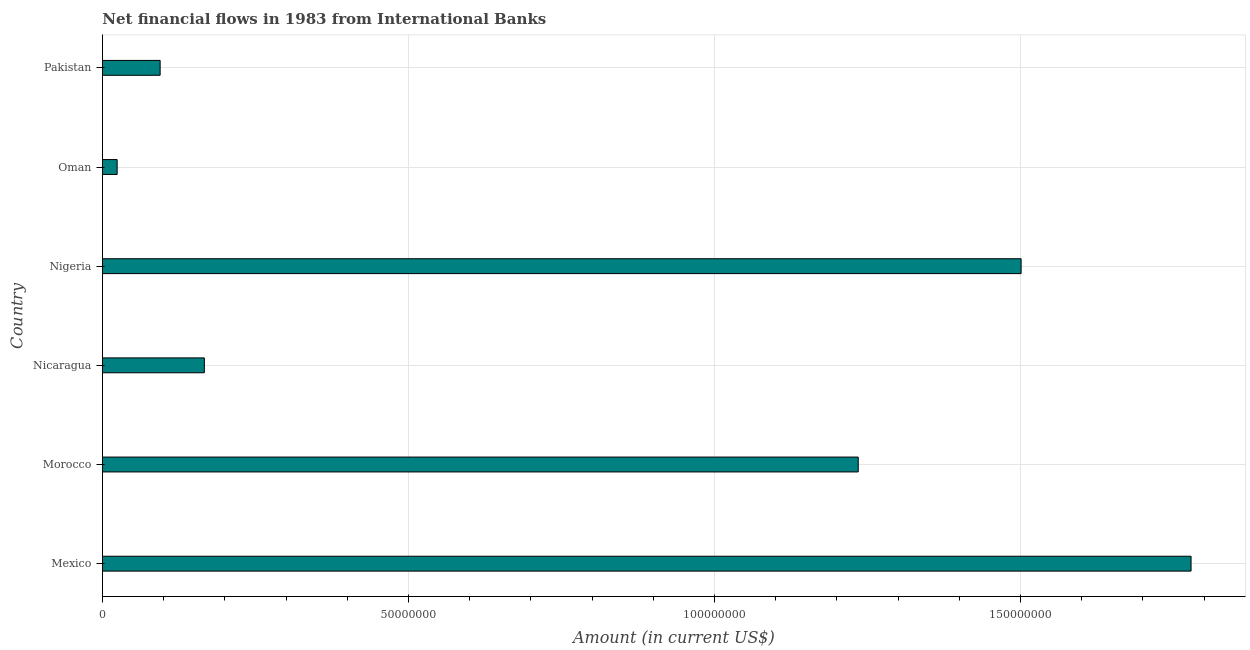Does the graph contain grids?
Your response must be concise. Yes. What is the title of the graph?
Offer a very short reply. Net financial flows in 1983 from International Banks. What is the label or title of the X-axis?
Your response must be concise. Amount (in current US$). What is the label or title of the Y-axis?
Give a very brief answer. Country. What is the net financial flows from ibrd in Mexico?
Your response must be concise. 1.78e+08. Across all countries, what is the maximum net financial flows from ibrd?
Provide a succinct answer. 1.78e+08. Across all countries, what is the minimum net financial flows from ibrd?
Ensure brevity in your answer.  2.40e+06. In which country was the net financial flows from ibrd maximum?
Ensure brevity in your answer.  Mexico. In which country was the net financial flows from ibrd minimum?
Make the answer very short. Oman. What is the sum of the net financial flows from ibrd?
Make the answer very short. 4.80e+08. What is the difference between the net financial flows from ibrd in Mexico and Oman?
Your answer should be very brief. 1.75e+08. What is the average net financial flows from ibrd per country?
Your response must be concise. 8.00e+07. What is the median net financial flows from ibrd?
Keep it short and to the point. 7.01e+07. What is the ratio of the net financial flows from ibrd in Nicaragua to that in Pakistan?
Offer a very short reply. 1.77. Is the net financial flows from ibrd in Oman less than that in Pakistan?
Keep it short and to the point. Yes. What is the difference between the highest and the second highest net financial flows from ibrd?
Keep it short and to the point. 2.78e+07. What is the difference between the highest and the lowest net financial flows from ibrd?
Your answer should be very brief. 1.75e+08. How many countries are there in the graph?
Ensure brevity in your answer.  6. What is the difference between two consecutive major ticks on the X-axis?
Your answer should be compact. 5.00e+07. Are the values on the major ticks of X-axis written in scientific E-notation?
Provide a succinct answer. No. What is the Amount (in current US$) of Mexico?
Offer a very short reply. 1.78e+08. What is the Amount (in current US$) in Morocco?
Keep it short and to the point. 1.23e+08. What is the Amount (in current US$) of Nicaragua?
Offer a very short reply. 1.66e+07. What is the Amount (in current US$) in Nigeria?
Keep it short and to the point. 1.50e+08. What is the Amount (in current US$) of Oman?
Your answer should be compact. 2.40e+06. What is the Amount (in current US$) of Pakistan?
Make the answer very short. 9.42e+06. What is the difference between the Amount (in current US$) in Mexico and Morocco?
Offer a terse response. 5.44e+07. What is the difference between the Amount (in current US$) in Mexico and Nicaragua?
Provide a short and direct response. 1.61e+08. What is the difference between the Amount (in current US$) in Mexico and Nigeria?
Ensure brevity in your answer.  2.78e+07. What is the difference between the Amount (in current US$) in Mexico and Oman?
Your response must be concise. 1.75e+08. What is the difference between the Amount (in current US$) in Mexico and Pakistan?
Your response must be concise. 1.68e+08. What is the difference between the Amount (in current US$) in Morocco and Nicaragua?
Offer a very short reply. 1.07e+08. What is the difference between the Amount (in current US$) in Morocco and Nigeria?
Offer a very short reply. -2.66e+07. What is the difference between the Amount (in current US$) in Morocco and Oman?
Keep it short and to the point. 1.21e+08. What is the difference between the Amount (in current US$) in Morocco and Pakistan?
Offer a very short reply. 1.14e+08. What is the difference between the Amount (in current US$) in Nicaragua and Nigeria?
Your answer should be compact. -1.33e+08. What is the difference between the Amount (in current US$) in Nicaragua and Oman?
Give a very brief answer. 1.42e+07. What is the difference between the Amount (in current US$) in Nicaragua and Pakistan?
Provide a short and direct response. 7.22e+06. What is the difference between the Amount (in current US$) in Nigeria and Oman?
Give a very brief answer. 1.48e+08. What is the difference between the Amount (in current US$) in Nigeria and Pakistan?
Offer a very short reply. 1.41e+08. What is the difference between the Amount (in current US$) in Oman and Pakistan?
Offer a terse response. -7.02e+06. What is the ratio of the Amount (in current US$) in Mexico to that in Morocco?
Give a very brief answer. 1.44. What is the ratio of the Amount (in current US$) in Mexico to that in Nicaragua?
Keep it short and to the point. 10.69. What is the ratio of the Amount (in current US$) in Mexico to that in Nigeria?
Give a very brief answer. 1.19. What is the ratio of the Amount (in current US$) in Mexico to that in Oman?
Your response must be concise. 74.11. What is the ratio of the Amount (in current US$) in Mexico to that in Pakistan?
Ensure brevity in your answer.  18.88. What is the ratio of the Amount (in current US$) in Morocco to that in Nicaragua?
Offer a terse response. 7.42. What is the ratio of the Amount (in current US$) in Morocco to that in Nigeria?
Your response must be concise. 0.82. What is the ratio of the Amount (in current US$) in Morocco to that in Oman?
Make the answer very short. 51.45. What is the ratio of the Amount (in current US$) in Morocco to that in Pakistan?
Give a very brief answer. 13.11. What is the ratio of the Amount (in current US$) in Nicaragua to that in Nigeria?
Provide a succinct answer. 0.11. What is the ratio of the Amount (in current US$) in Nicaragua to that in Oman?
Offer a terse response. 6.94. What is the ratio of the Amount (in current US$) in Nicaragua to that in Pakistan?
Make the answer very short. 1.77. What is the ratio of the Amount (in current US$) in Nigeria to that in Oman?
Your response must be concise. 62.54. What is the ratio of the Amount (in current US$) in Nigeria to that in Pakistan?
Ensure brevity in your answer.  15.93. What is the ratio of the Amount (in current US$) in Oman to that in Pakistan?
Your response must be concise. 0.26. 